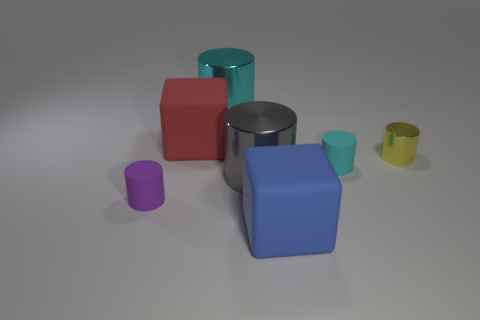There is a big blue thing that is made of the same material as the small purple cylinder; what is its shape?
Offer a terse response. Cube. Are there any other things that have the same shape as the purple thing?
Ensure brevity in your answer.  Yes. There is a small cyan rubber thing; what shape is it?
Keep it short and to the point. Cylinder. There is a tiny matte object left of the red rubber object; is its shape the same as the gray metal thing?
Your response must be concise. Yes. Is the number of purple cylinders to the right of the blue block greater than the number of large blue cubes that are behind the small cyan object?
Ensure brevity in your answer.  No. How many other objects are there of the same size as the gray metallic cylinder?
Provide a succinct answer. 3. There is a large gray metal object; is its shape the same as the big matte object that is in front of the big red object?
Give a very brief answer. No. How many metal objects are either big red cubes or big gray things?
Offer a very short reply. 1. Is there a tiny matte thing of the same color as the small metal cylinder?
Your answer should be very brief. No. Are any small cyan rubber cylinders visible?
Your answer should be compact. Yes. 